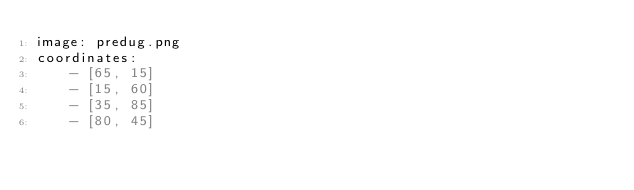Convert code to text. <code><loc_0><loc_0><loc_500><loc_500><_YAML_>image: predug.png
coordinates:
    - [65, 15]
    - [15, 60]
    - [35, 85]
    - [80, 45]
</code> 